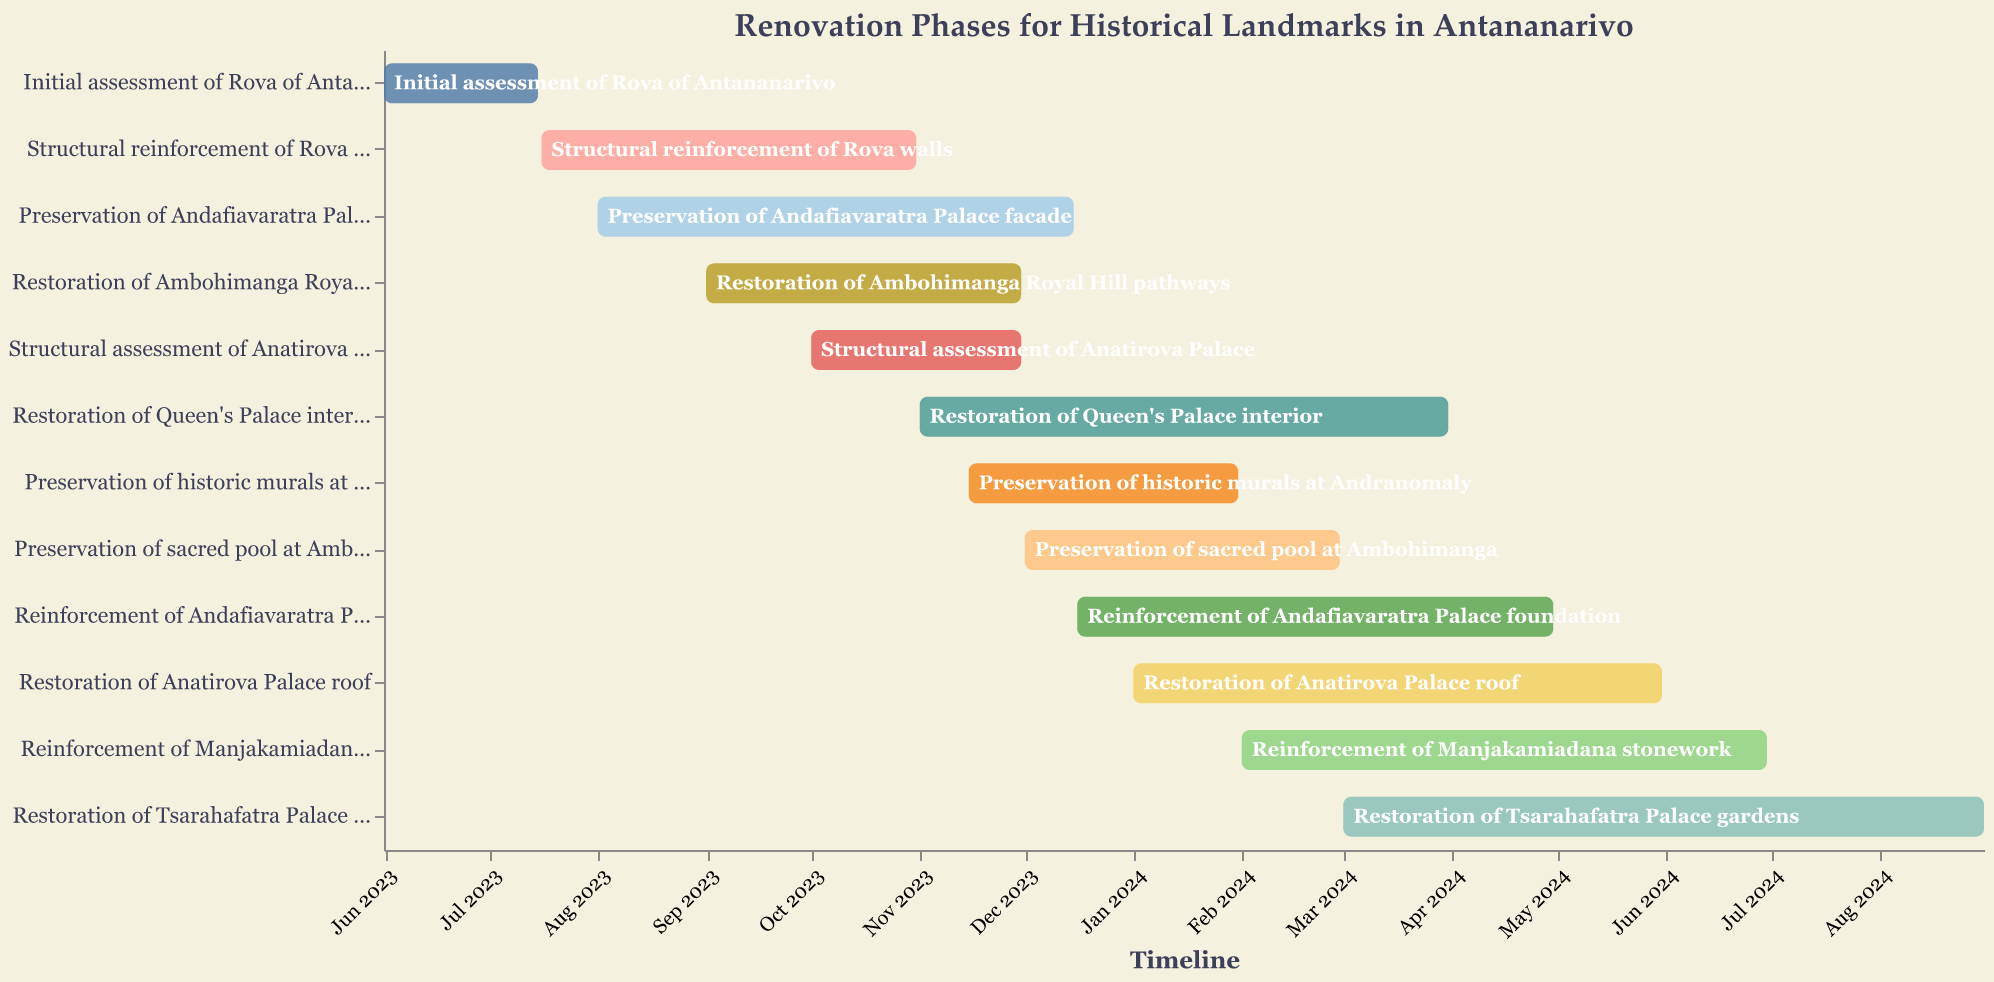Which task starts first? By looking at the timeline, the "Initial assessment of Rova of Antananarivo" starts on June 1, 2023, which is the earliest start date among all tasks.
Answer: Initial assessment of Rova of Antananarivo Which task ends last? By scanning through the end dates of the tasks, the "Restoration of Tsarahafatra Palace gardens" ends on August 31, 2024, which is the latest end date.
Answer: Restoration of Tsarahafatra Palace gardens What's the duration of the Structural reinforcement of Rova walls? The task starts on July 16, 2023, and ends on October 31, 2023. The duration can be calculated by counting the number of days between these dates.
Answer: Approximately 3.5 months How many tasks are active during December 2023? By examining the timeline, the tasks during December 2023 are "Preservation of Andafiavaratra Palace facade," "Reinforcement of Andafiavaratra Palace foundation," "Restoration of Ambohimanga Royal Hill pathways," "Preservation of sacred pool at Ambohimanga," "Structural assessment of Anatirova Palace," and "Preservation of historic murals at Andranomaly." Count these tasks.
Answer: 6 Which site has the longest single phase of restoration? By checking the duration of each task, "Restoration of Tsarahafatra Palace gardens" lasts from March 1, 2024, to August 31, 2024, which is 6 months and the longest single phase.
Answer: Tsarahafatra Palace When does the Restoration of Queen's Palace interior start and finish? The task "Restoration of Queen's Palace interior" starts on November 1, 2023, and ends on March 31, 2024.
Answer: November 1, 2023, to March 31, 2024 Which tasks overlap with the Structural reinforcement of Rova walls? The "Structural reinforcement of Rova walls" spans from July 16, 2023, to October 31, 2023. Tasks overlapping in this period are "Preservation of Andafiavaratra Palace facade" and "Restoration of Ambohimanga Royal Hill pathways."
Answer: Preservation of Andafiavaratra Palace facade, Restoration of Ambohimanga Royal Hill pathways What is the combined duration of restoration tasks for Ambohimanga? "Restoration of Ambohimanga Royal Hill pathways" is from September 1, 2023, to November 30, 2023, and "Preservation of sacred pool at Ambohimanga" is from December 1, 2023, to February 29, 2024. The combined duration is (3 months + 3 months).
Answer: 6 months How many tasks involve assessments? There are two tasks involving assessments: "Initial assessment of Rova of Antananarivo" and "Structural assessment of Anatirova Palace."
Answer: 2 Which task runs concurrently with the "Reinforcement of Manjakamiadana stonework" for the longest period? The "Reinforcement of Manjakamiadana stonework" runs from February 1, 2024, to June 30, 2024. "Restoration of Tsarahafatra Palace gardens" runs concurrently for the longest period from March 1, 2024, to June 30, 2024.
Answer: Restoration of Tsarahafatra Palace gardens 